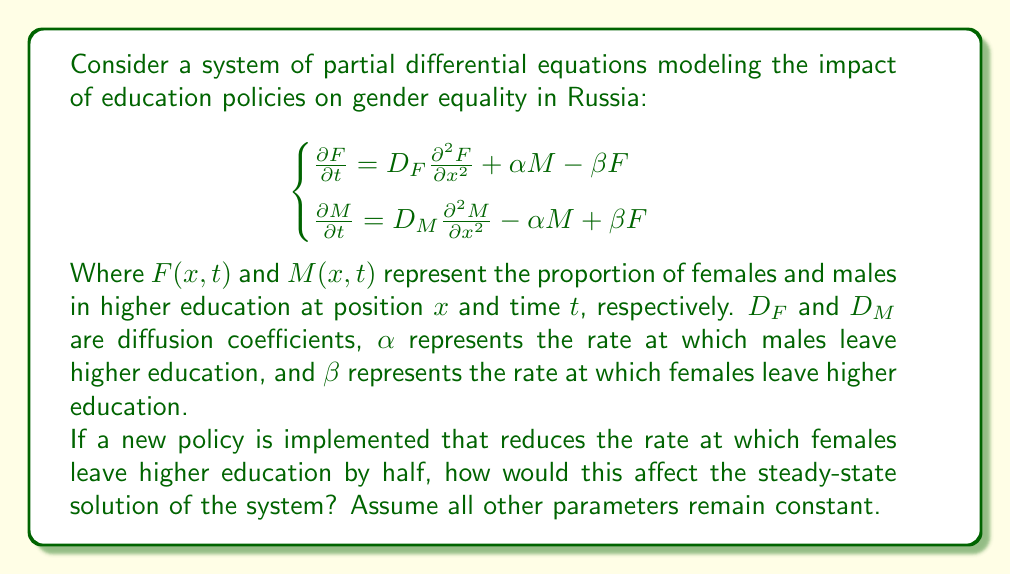Can you solve this math problem? To solve this problem, we need to follow these steps:

1) First, let's understand what a steady-state solution means. In a steady-state, the system doesn't change with time, so we set all time derivatives to zero:

$$\begin{cases}
0 = D_F \frac{\partial^2 F}{\partial x^2} + \alpha M - \beta F \\
0 = D_M \frac{\partial^2 M}{\partial x^2} - \alpha M + \beta F
\end{cases}$$

2) In a homogeneous steady-state, we also assume that the solution doesn't depend on position $x$, so all spatial derivatives are also zero:

$$\begin{cases}
0 = \alpha M - \beta F \\
0 = - \alpha M + \beta F
\end{cases}$$

3) These equations are actually the same, so we can focus on one:

$$\alpha M = \beta F$$

4) This tells us that in the steady-state, the ratio of males to females in higher education is:

$$\frac{M}{F} = \frac{\beta}{\alpha}$$

5) Now, if a new policy reduces the rate at which females leave higher education by half, it means the new $\beta$ (let's call it $\beta_{new}$) is:

$$\beta_{new} = \frac{1}{2}\beta$$

6) With this new $\beta$, the new steady-state ratio will be:

$$\frac{M}{F}_{new} = \frac{\beta_{new}}{\alpha} = \frac{\beta/2}{\alpha} = \frac{1}{2} \cdot \frac{\beta}{\alpha}$$

7) This means the new ratio is half of what it was before.
Answer: The new policy that reduces the rate at which females leave higher education by half will result in the steady-state ratio of males to females in higher education being reduced by half compared to the original ratio. Mathematically, if the original ratio was $\frac{M}{F} = \frac{\beta}{\alpha}$, the new ratio will be $\frac{M}{F}_{new} = \frac{1}{2} \cdot \frac{\beta}{\alpha}$. 